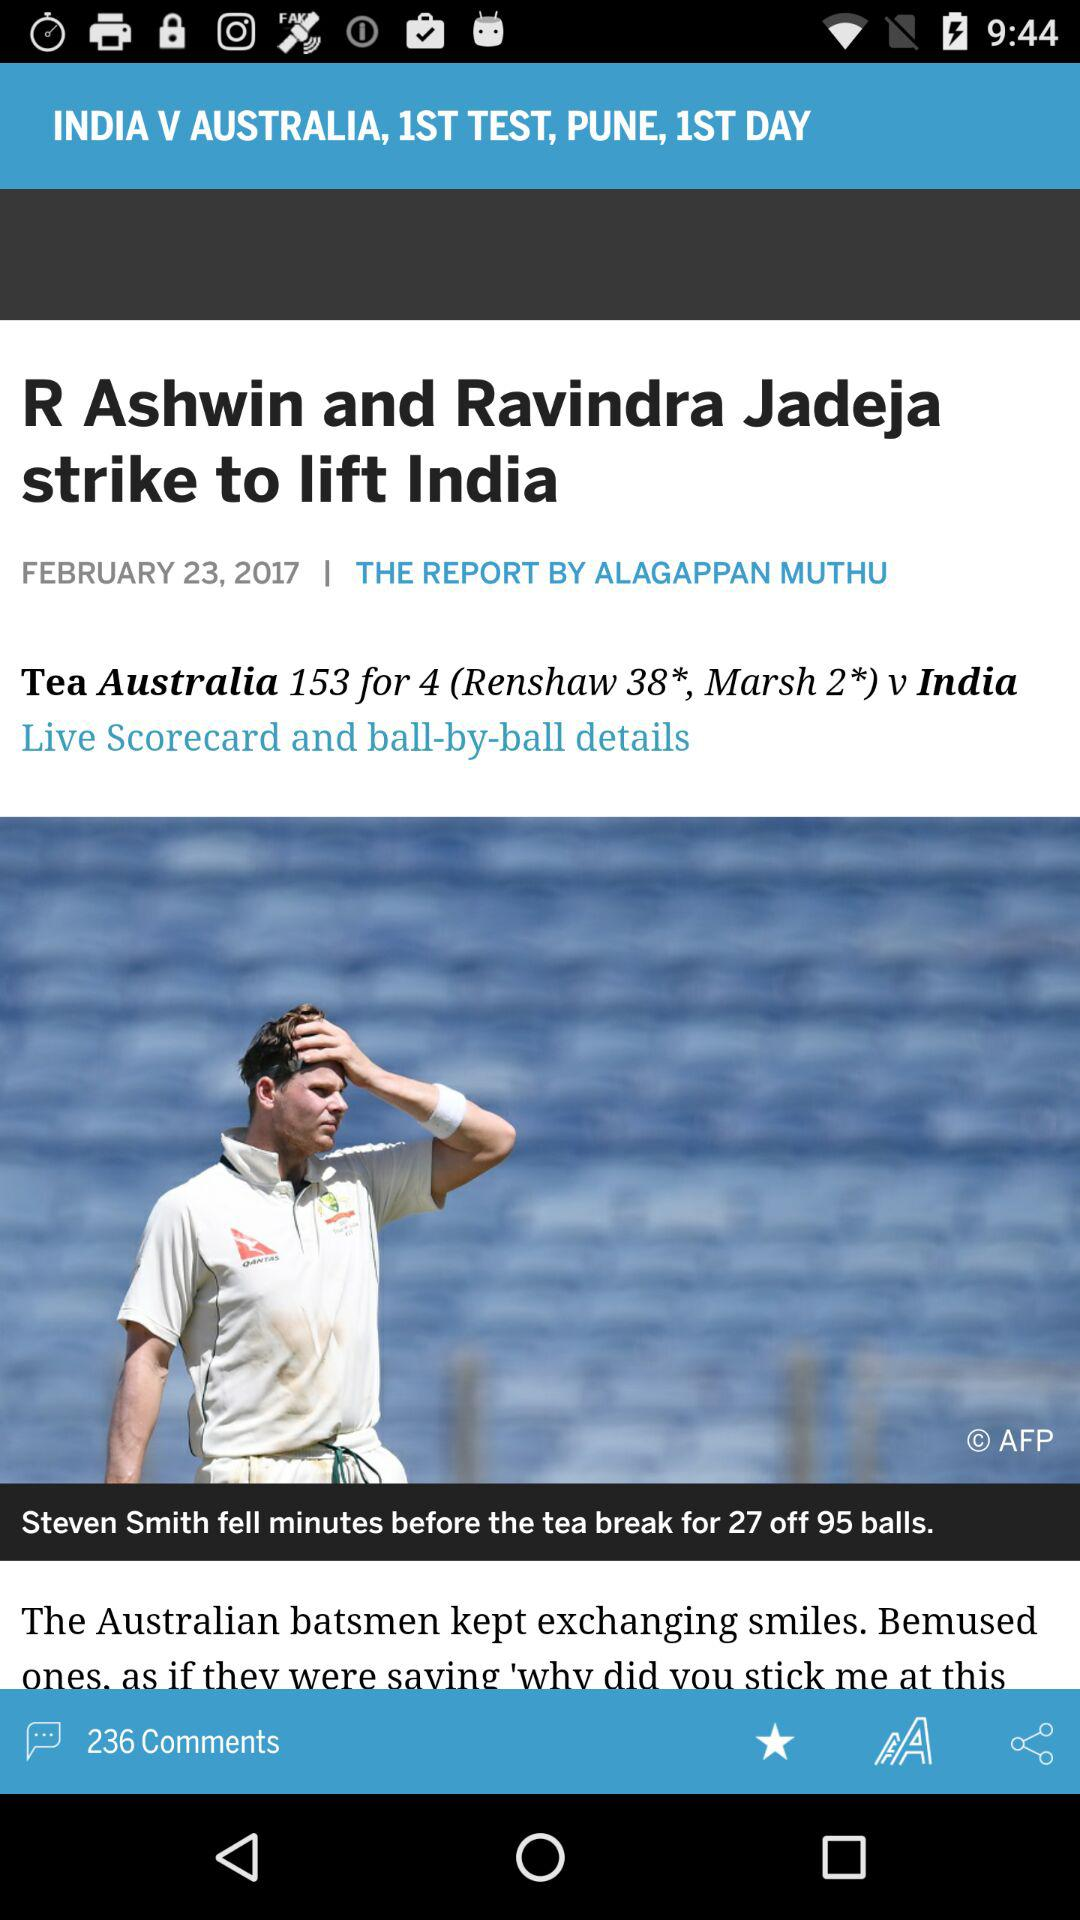What is the city name for the match? The city is Pune. 